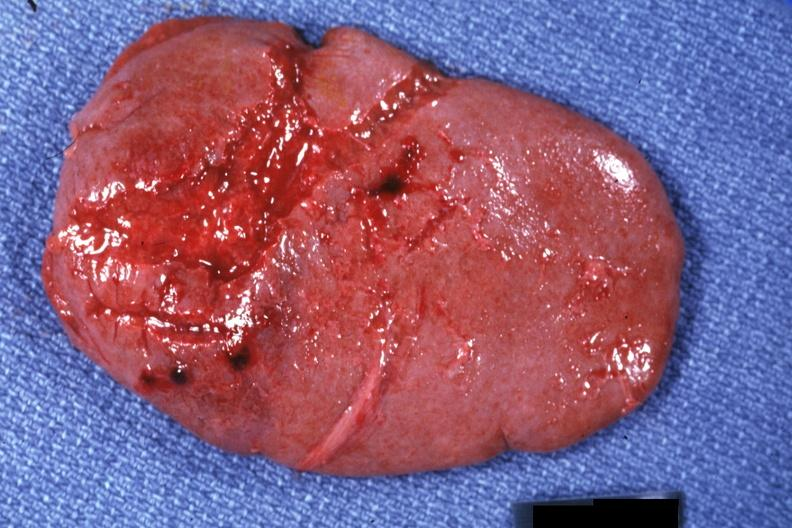where is this part in?
Answer the question using a single word or phrase. Spleen 